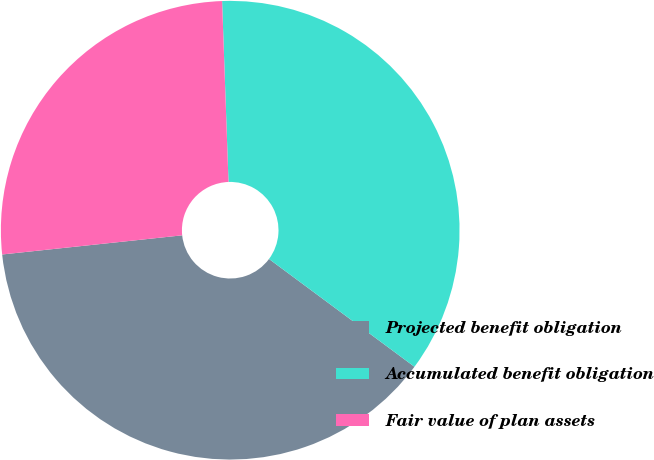Convert chart to OTSL. <chart><loc_0><loc_0><loc_500><loc_500><pie_chart><fcel>Projected benefit obligation<fcel>Accumulated benefit obligation<fcel>Fair value of plan assets<nl><fcel>38.16%<fcel>35.71%<fcel>26.12%<nl></chart> 